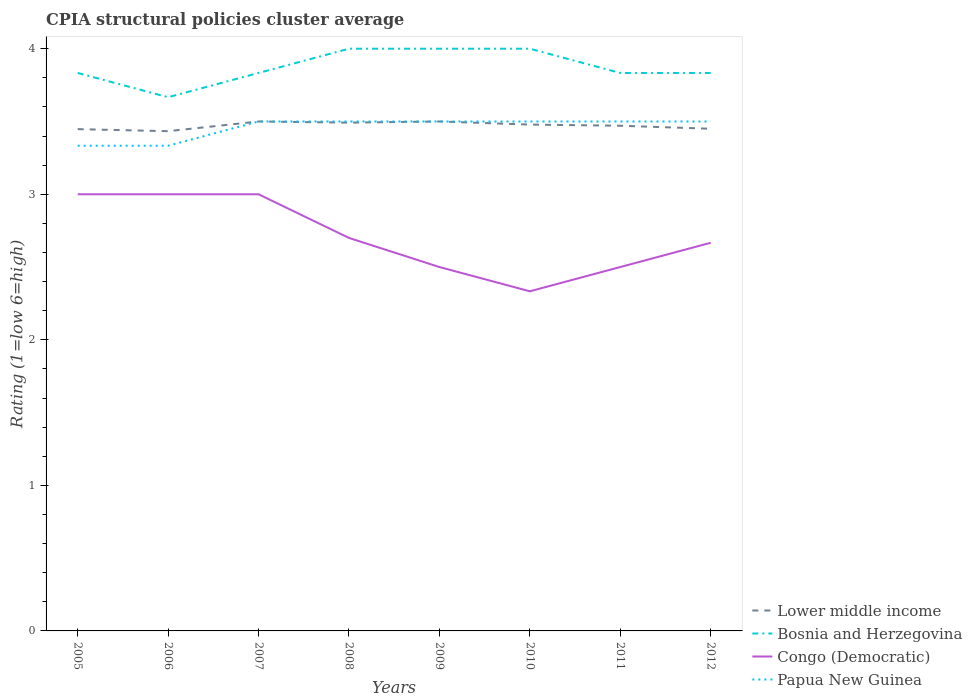Does the line corresponding to Bosnia and Herzegovina intersect with the line corresponding to Lower middle income?
Offer a very short reply. No. Across all years, what is the maximum CPIA rating in Congo (Democratic)?
Offer a terse response. 2.33. In which year was the CPIA rating in Congo (Democratic) maximum?
Provide a short and direct response. 2010. What is the total CPIA rating in Lower middle income in the graph?
Your answer should be compact. 0.02. What is the difference between the highest and the second highest CPIA rating in Congo (Democratic)?
Offer a very short reply. 0.67. What is the difference between the highest and the lowest CPIA rating in Papua New Guinea?
Your response must be concise. 6. Is the CPIA rating in Bosnia and Herzegovina strictly greater than the CPIA rating in Congo (Democratic) over the years?
Your response must be concise. No. How many lines are there?
Ensure brevity in your answer.  4. What is the difference between two consecutive major ticks on the Y-axis?
Make the answer very short. 1. Are the values on the major ticks of Y-axis written in scientific E-notation?
Keep it short and to the point. No. Does the graph contain grids?
Keep it short and to the point. No. Where does the legend appear in the graph?
Provide a succinct answer. Bottom right. How many legend labels are there?
Give a very brief answer. 4. What is the title of the graph?
Your response must be concise. CPIA structural policies cluster average. Does "French Polynesia" appear as one of the legend labels in the graph?
Keep it short and to the point. No. What is the label or title of the Y-axis?
Make the answer very short. Rating (1=low 6=high). What is the Rating (1=low 6=high) in Lower middle income in 2005?
Offer a very short reply. 3.45. What is the Rating (1=low 6=high) of Bosnia and Herzegovina in 2005?
Keep it short and to the point. 3.83. What is the Rating (1=low 6=high) in Papua New Guinea in 2005?
Give a very brief answer. 3.33. What is the Rating (1=low 6=high) of Lower middle income in 2006?
Provide a succinct answer. 3.43. What is the Rating (1=low 6=high) in Bosnia and Herzegovina in 2006?
Offer a very short reply. 3.67. What is the Rating (1=low 6=high) in Papua New Guinea in 2006?
Your answer should be compact. 3.33. What is the Rating (1=low 6=high) of Bosnia and Herzegovina in 2007?
Keep it short and to the point. 3.83. What is the Rating (1=low 6=high) of Papua New Guinea in 2007?
Ensure brevity in your answer.  3.5. What is the Rating (1=low 6=high) in Lower middle income in 2008?
Give a very brief answer. 3.49. What is the Rating (1=low 6=high) in Papua New Guinea in 2009?
Your answer should be compact. 3.5. What is the Rating (1=low 6=high) of Lower middle income in 2010?
Your answer should be very brief. 3.48. What is the Rating (1=low 6=high) in Congo (Democratic) in 2010?
Make the answer very short. 2.33. What is the Rating (1=low 6=high) of Papua New Guinea in 2010?
Offer a terse response. 3.5. What is the Rating (1=low 6=high) of Lower middle income in 2011?
Provide a short and direct response. 3.47. What is the Rating (1=low 6=high) of Bosnia and Herzegovina in 2011?
Your response must be concise. 3.83. What is the Rating (1=low 6=high) of Congo (Democratic) in 2011?
Offer a terse response. 2.5. What is the Rating (1=low 6=high) of Lower middle income in 2012?
Your response must be concise. 3.45. What is the Rating (1=low 6=high) in Bosnia and Herzegovina in 2012?
Offer a very short reply. 3.83. What is the Rating (1=low 6=high) of Congo (Democratic) in 2012?
Your answer should be compact. 2.67. Across all years, what is the maximum Rating (1=low 6=high) of Lower middle income?
Offer a very short reply. 3.5. Across all years, what is the maximum Rating (1=low 6=high) of Congo (Democratic)?
Give a very brief answer. 3. Across all years, what is the minimum Rating (1=low 6=high) of Lower middle income?
Ensure brevity in your answer.  3.43. Across all years, what is the minimum Rating (1=low 6=high) in Bosnia and Herzegovina?
Your response must be concise. 3.67. Across all years, what is the minimum Rating (1=low 6=high) in Congo (Democratic)?
Give a very brief answer. 2.33. Across all years, what is the minimum Rating (1=low 6=high) of Papua New Guinea?
Keep it short and to the point. 3.33. What is the total Rating (1=low 6=high) of Lower middle income in the graph?
Provide a short and direct response. 27.77. What is the total Rating (1=low 6=high) in Congo (Democratic) in the graph?
Make the answer very short. 21.7. What is the total Rating (1=low 6=high) of Papua New Guinea in the graph?
Offer a terse response. 27.67. What is the difference between the Rating (1=low 6=high) of Lower middle income in 2005 and that in 2006?
Offer a terse response. 0.01. What is the difference between the Rating (1=low 6=high) in Congo (Democratic) in 2005 and that in 2006?
Your answer should be very brief. 0. What is the difference between the Rating (1=low 6=high) of Lower middle income in 2005 and that in 2007?
Provide a succinct answer. -0.05. What is the difference between the Rating (1=low 6=high) in Congo (Democratic) in 2005 and that in 2007?
Make the answer very short. 0. What is the difference between the Rating (1=low 6=high) in Papua New Guinea in 2005 and that in 2007?
Make the answer very short. -0.17. What is the difference between the Rating (1=low 6=high) in Lower middle income in 2005 and that in 2008?
Your answer should be very brief. -0.04. What is the difference between the Rating (1=low 6=high) of Lower middle income in 2005 and that in 2009?
Your response must be concise. -0.05. What is the difference between the Rating (1=low 6=high) in Lower middle income in 2005 and that in 2010?
Offer a terse response. -0.03. What is the difference between the Rating (1=low 6=high) in Bosnia and Herzegovina in 2005 and that in 2010?
Ensure brevity in your answer.  -0.17. What is the difference between the Rating (1=low 6=high) of Congo (Democratic) in 2005 and that in 2010?
Your answer should be compact. 0.67. What is the difference between the Rating (1=low 6=high) of Papua New Guinea in 2005 and that in 2010?
Make the answer very short. -0.17. What is the difference between the Rating (1=low 6=high) in Lower middle income in 2005 and that in 2011?
Provide a succinct answer. -0.02. What is the difference between the Rating (1=low 6=high) of Bosnia and Herzegovina in 2005 and that in 2011?
Your answer should be compact. 0. What is the difference between the Rating (1=low 6=high) in Congo (Democratic) in 2005 and that in 2011?
Provide a succinct answer. 0.5. What is the difference between the Rating (1=low 6=high) in Lower middle income in 2005 and that in 2012?
Your response must be concise. -0. What is the difference between the Rating (1=low 6=high) in Papua New Guinea in 2005 and that in 2012?
Your answer should be compact. -0.17. What is the difference between the Rating (1=low 6=high) of Lower middle income in 2006 and that in 2007?
Your answer should be very brief. -0.07. What is the difference between the Rating (1=low 6=high) of Bosnia and Herzegovina in 2006 and that in 2007?
Your answer should be compact. -0.17. What is the difference between the Rating (1=low 6=high) of Congo (Democratic) in 2006 and that in 2007?
Make the answer very short. 0. What is the difference between the Rating (1=low 6=high) of Lower middle income in 2006 and that in 2008?
Provide a succinct answer. -0.06. What is the difference between the Rating (1=low 6=high) of Congo (Democratic) in 2006 and that in 2008?
Your response must be concise. 0.3. What is the difference between the Rating (1=low 6=high) of Lower middle income in 2006 and that in 2009?
Offer a terse response. -0.07. What is the difference between the Rating (1=low 6=high) in Papua New Guinea in 2006 and that in 2009?
Make the answer very short. -0.17. What is the difference between the Rating (1=low 6=high) in Lower middle income in 2006 and that in 2010?
Provide a short and direct response. -0.05. What is the difference between the Rating (1=low 6=high) of Bosnia and Herzegovina in 2006 and that in 2010?
Your answer should be very brief. -0.33. What is the difference between the Rating (1=low 6=high) of Lower middle income in 2006 and that in 2011?
Give a very brief answer. -0.04. What is the difference between the Rating (1=low 6=high) of Congo (Democratic) in 2006 and that in 2011?
Keep it short and to the point. 0.5. What is the difference between the Rating (1=low 6=high) in Lower middle income in 2006 and that in 2012?
Ensure brevity in your answer.  -0.02. What is the difference between the Rating (1=low 6=high) of Congo (Democratic) in 2006 and that in 2012?
Your answer should be compact. 0.33. What is the difference between the Rating (1=low 6=high) of Papua New Guinea in 2006 and that in 2012?
Offer a terse response. -0.17. What is the difference between the Rating (1=low 6=high) in Lower middle income in 2007 and that in 2008?
Keep it short and to the point. 0.01. What is the difference between the Rating (1=low 6=high) in Papua New Guinea in 2007 and that in 2008?
Keep it short and to the point. 0. What is the difference between the Rating (1=low 6=high) of Congo (Democratic) in 2007 and that in 2009?
Ensure brevity in your answer.  0.5. What is the difference between the Rating (1=low 6=high) in Lower middle income in 2007 and that in 2010?
Your response must be concise. 0.02. What is the difference between the Rating (1=low 6=high) in Bosnia and Herzegovina in 2007 and that in 2010?
Provide a short and direct response. -0.17. What is the difference between the Rating (1=low 6=high) in Lower middle income in 2007 and that in 2011?
Provide a short and direct response. 0.03. What is the difference between the Rating (1=low 6=high) of Congo (Democratic) in 2007 and that in 2011?
Make the answer very short. 0.5. What is the difference between the Rating (1=low 6=high) in Papua New Guinea in 2007 and that in 2011?
Give a very brief answer. 0. What is the difference between the Rating (1=low 6=high) of Lower middle income in 2007 and that in 2012?
Provide a short and direct response. 0.05. What is the difference between the Rating (1=low 6=high) in Papua New Guinea in 2007 and that in 2012?
Give a very brief answer. 0. What is the difference between the Rating (1=low 6=high) in Lower middle income in 2008 and that in 2009?
Give a very brief answer. -0.01. What is the difference between the Rating (1=low 6=high) of Bosnia and Herzegovina in 2008 and that in 2009?
Offer a very short reply. 0. What is the difference between the Rating (1=low 6=high) of Congo (Democratic) in 2008 and that in 2009?
Keep it short and to the point. 0.2. What is the difference between the Rating (1=low 6=high) in Papua New Guinea in 2008 and that in 2009?
Keep it short and to the point. 0. What is the difference between the Rating (1=low 6=high) in Lower middle income in 2008 and that in 2010?
Provide a short and direct response. 0.01. What is the difference between the Rating (1=low 6=high) of Congo (Democratic) in 2008 and that in 2010?
Your answer should be compact. 0.37. What is the difference between the Rating (1=low 6=high) in Papua New Guinea in 2008 and that in 2010?
Provide a short and direct response. 0. What is the difference between the Rating (1=low 6=high) of Lower middle income in 2008 and that in 2011?
Ensure brevity in your answer.  0.02. What is the difference between the Rating (1=low 6=high) in Lower middle income in 2008 and that in 2012?
Provide a short and direct response. 0.04. What is the difference between the Rating (1=low 6=high) of Bosnia and Herzegovina in 2008 and that in 2012?
Your response must be concise. 0.17. What is the difference between the Rating (1=low 6=high) in Congo (Democratic) in 2008 and that in 2012?
Give a very brief answer. 0.03. What is the difference between the Rating (1=low 6=high) of Papua New Guinea in 2008 and that in 2012?
Make the answer very short. 0. What is the difference between the Rating (1=low 6=high) in Lower middle income in 2009 and that in 2010?
Your answer should be very brief. 0.02. What is the difference between the Rating (1=low 6=high) in Bosnia and Herzegovina in 2009 and that in 2010?
Your answer should be very brief. 0. What is the difference between the Rating (1=low 6=high) of Lower middle income in 2009 and that in 2011?
Provide a succinct answer. 0.03. What is the difference between the Rating (1=low 6=high) of Congo (Democratic) in 2009 and that in 2011?
Provide a short and direct response. 0. What is the difference between the Rating (1=low 6=high) of Papua New Guinea in 2009 and that in 2011?
Give a very brief answer. 0. What is the difference between the Rating (1=low 6=high) of Papua New Guinea in 2009 and that in 2012?
Provide a short and direct response. 0. What is the difference between the Rating (1=low 6=high) of Lower middle income in 2010 and that in 2011?
Your response must be concise. 0.01. What is the difference between the Rating (1=low 6=high) of Lower middle income in 2010 and that in 2012?
Provide a short and direct response. 0.03. What is the difference between the Rating (1=low 6=high) of Bosnia and Herzegovina in 2010 and that in 2012?
Give a very brief answer. 0.17. What is the difference between the Rating (1=low 6=high) in Congo (Democratic) in 2010 and that in 2012?
Your answer should be compact. -0.33. What is the difference between the Rating (1=low 6=high) in Lower middle income in 2011 and that in 2012?
Your answer should be very brief. 0.02. What is the difference between the Rating (1=low 6=high) of Bosnia and Herzegovina in 2011 and that in 2012?
Your answer should be very brief. 0. What is the difference between the Rating (1=low 6=high) of Lower middle income in 2005 and the Rating (1=low 6=high) of Bosnia and Herzegovina in 2006?
Provide a succinct answer. -0.22. What is the difference between the Rating (1=low 6=high) in Lower middle income in 2005 and the Rating (1=low 6=high) in Congo (Democratic) in 2006?
Make the answer very short. 0.45. What is the difference between the Rating (1=low 6=high) of Lower middle income in 2005 and the Rating (1=low 6=high) of Papua New Guinea in 2006?
Provide a short and direct response. 0.11. What is the difference between the Rating (1=low 6=high) of Bosnia and Herzegovina in 2005 and the Rating (1=low 6=high) of Congo (Democratic) in 2006?
Give a very brief answer. 0.83. What is the difference between the Rating (1=low 6=high) of Lower middle income in 2005 and the Rating (1=low 6=high) of Bosnia and Herzegovina in 2007?
Your answer should be very brief. -0.39. What is the difference between the Rating (1=low 6=high) in Lower middle income in 2005 and the Rating (1=low 6=high) in Congo (Democratic) in 2007?
Provide a succinct answer. 0.45. What is the difference between the Rating (1=low 6=high) of Lower middle income in 2005 and the Rating (1=low 6=high) of Papua New Guinea in 2007?
Make the answer very short. -0.05. What is the difference between the Rating (1=low 6=high) of Bosnia and Herzegovina in 2005 and the Rating (1=low 6=high) of Congo (Democratic) in 2007?
Your answer should be compact. 0.83. What is the difference between the Rating (1=low 6=high) of Congo (Democratic) in 2005 and the Rating (1=low 6=high) of Papua New Guinea in 2007?
Your answer should be very brief. -0.5. What is the difference between the Rating (1=low 6=high) of Lower middle income in 2005 and the Rating (1=low 6=high) of Bosnia and Herzegovina in 2008?
Offer a very short reply. -0.55. What is the difference between the Rating (1=low 6=high) of Lower middle income in 2005 and the Rating (1=low 6=high) of Congo (Democratic) in 2008?
Offer a terse response. 0.75. What is the difference between the Rating (1=low 6=high) of Lower middle income in 2005 and the Rating (1=low 6=high) of Papua New Guinea in 2008?
Provide a succinct answer. -0.05. What is the difference between the Rating (1=low 6=high) of Bosnia and Herzegovina in 2005 and the Rating (1=low 6=high) of Congo (Democratic) in 2008?
Provide a short and direct response. 1.13. What is the difference between the Rating (1=low 6=high) in Bosnia and Herzegovina in 2005 and the Rating (1=low 6=high) in Papua New Guinea in 2008?
Your answer should be compact. 0.33. What is the difference between the Rating (1=low 6=high) of Lower middle income in 2005 and the Rating (1=low 6=high) of Bosnia and Herzegovina in 2009?
Make the answer very short. -0.55. What is the difference between the Rating (1=low 6=high) in Lower middle income in 2005 and the Rating (1=low 6=high) in Papua New Guinea in 2009?
Keep it short and to the point. -0.05. What is the difference between the Rating (1=low 6=high) in Congo (Democratic) in 2005 and the Rating (1=low 6=high) in Papua New Guinea in 2009?
Your answer should be compact. -0.5. What is the difference between the Rating (1=low 6=high) in Lower middle income in 2005 and the Rating (1=low 6=high) in Bosnia and Herzegovina in 2010?
Ensure brevity in your answer.  -0.55. What is the difference between the Rating (1=low 6=high) in Lower middle income in 2005 and the Rating (1=low 6=high) in Congo (Democratic) in 2010?
Offer a terse response. 1.11. What is the difference between the Rating (1=low 6=high) of Lower middle income in 2005 and the Rating (1=low 6=high) of Papua New Guinea in 2010?
Give a very brief answer. -0.05. What is the difference between the Rating (1=low 6=high) of Bosnia and Herzegovina in 2005 and the Rating (1=low 6=high) of Congo (Democratic) in 2010?
Keep it short and to the point. 1.5. What is the difference between the Rating (1=low 6=high) of Lower middle income in 2005 and the Rating (1=low 6=high) of Bosnia and Herzegovina in 2011?
Provide a succinct answer. -0.39. What is the difference between the Rating (1=low 6=high) in Lower middle income in 2005 and the Rating (1=low 6=high) in Congo (Democratic) in 2011?
Keep it short and to the point. 0.95. What is the difference between the Rating (1=low 6=high) of Lower middle income in 2005 and the Rating (1=low 6=high) of Papua New Guinea in 2011?
Offer a terse response. -0.05. What is the difference between the Rating (1=low 6=high) of Bosnia and Herzegovina in 2005 and the Rating (1=low 6=high) of Congo (Democratic) in 2011?
Give a very brief answer. 1.33. What is the difference between the Rating (1=low 6=high) of Lower middle income in 2005 and the Rating (1=low 6=high) of Bosnia and Herzegovina in 2012?
Ensure brevity in your answer.  -0.39. What is the difference between the Rating (1=low 6=high) of Lower middle income in 2005 and the Rating (1=low 6=high) of Congo (Democratic) in 2012?
Offer a terse response. 0.78. What is the difference between the Rating (1=low 6=high) of Lower middle income in 2005 and the Rating (1=low 6=high) of Papua New Guinea in 2012?
Your response must be concise. -0.05. What is the difference between the Rating (1=low 6=high) in Bosnia and Herzegovina in 2005 and the Rating (1=low 6=high) in Papua New Guinea in 2012?
Make the answer very short. 0.33. What is the difference between the Rating (1=low 6=high) of Congo (Democratic) in 2005 and the Rating (1=low 6=high) of Papua New Guinea in 2012?
Offer a terse response. -0.5. What is the difference between the Rating (1=low 6=high) of Lower middle income in 2006 and the Rating (1=low 6=high) of Bosnia and Herzegovina in 2007?
Your answer should be compact. -0.4. What is the difference between the Rating (1=low 6=high) in Lower middle income in 2006 and the Rating (1=low 6=high) in Congo (Democratic) in 2007?
Ensure brevity in your answer.  0.43. What is the difference between the Rating (1=low 6=high) in Lower middle income in 2006 and the Rating (1=low 6=high) in Papua New Guinea in 2007?
Offer a terse response. -0.07. What is the difference between the Rating (1=low 6=high) in Bosnia and Herzegovina in 2006 and the Rating (1=low 6=high) in Congo (Democratic) in 2007?
Offer a very short reply. 0.67. What is the difference between the Rating (1=low 6=high) of Congo (Democratic) in 2006 and the Rating (1=low 6=high) of Papua New Guinea in 2007?
Keep it short and to the point. -0.5. What is the difference between the Rating (1=low 6=high) in Lower middle income in 2006 and the Rating (1=low 6=high) in Bosnia and Herzegovina in 2008?
Provide a short and direct response. -0.57. What is the difference between the Rating (1=low 6=high) of Lower middle income in 2006 and the Rating (1=low 6=high) of Congo (Democratic) in 2008?
Keep it short and to the point. 0.73. What is the difference between the Rating (1=low 6=high) in Lower middle income in 2006 and the Rating (1=low 6=high) in Papua New Guinea in 2008?
Provide a short and direct response. -0.07. What is the difference between the Rating (1=low 6=high) in Bosnia and Herzegovina in 2006 and the Rating (1=low 6=high) in Congo (Democratic) in 2008?
Offer a very short reply. 0.97. What is the difference between the Rating (1=low 6=high) of Lower middle income in 2006 and the Rating (1=low 6=high) of Bosnia and Herzegovina in 2009?
Offer a very short reply. -0.57. What is the difference between the Rating (1=low 6=high) in Lower middle income in 2006 and the Rating (1=low 6=high) in Congo (Democratic) in 2009?
Your answer should be very brief. 0.93. What is the difference between the Rating (1=low 6=high) in Lower middle income in 2006 and the Rating (1=low 6=high) in Papua New Guinea in 2009?
Ensure brevity in your answer.  -0.07. What is the difference between the Rating (1=low 6=high) of Congo (Democratic) in 2006 and the Rating (1=low 6=high) of Papua New Guinea in 2009?
Make the answer very short. -0.5. What is the difference between the Rating (1=low 6=high) in Lower middle income in 2006 and the Rating (1=low 6=high) in Bosnia and Herzegovina in 2010?
Offer a very short reply. -0.57. What is the difference between the Rating (1=low 6=high) in Lower middle income in 2006 and the Rating (1=low 6=high) in Congo (Democratic) in 2010?
Your answer should be very brief. 1.1. What is the difference between the Rating (1=low 6=high) of Lower middle income in 2006 and the Rating (1=low 6=high) of Papua New Guinea in 2010?
Offer a very short reply. -0.07. What is the difference between the Rating (1=low 6=high) of Bosnia and Herzegovina in 2006 and the Rating (1=low 6=high) of Papua New Guinea in 2010?
Make the answer very short. 0.17. What is the difference between the Rating (1=low 6=high) of Congo (Democratic) in 2006 and the Rating (1=low 6=high) of Papua New Guinea in 2010?
Ensure brevity in your answer.  -0.5. What is the difference between the Rating (1=low 6=high) in Lower middle income in 2006 and the Rating (1=low 6=high) in Bosnia and Herzegovina in 2011?
Keep it short and to the point. -0.4. What is the difference between the Rating (1=low 6=high) of Lower middle income in 2006 and the Rating (1=low 6=high) of Congo (Democratic) in 2011?
Give a very brief answer. 0.93. What is the difference between the Rating (1=low 6=high) in Lower middle income in 2006 and the Rating (1=low 6=high) in Papua New Guinea in 2011?
Your answer should be compact. -0.07. What is the difference between the Rating (1=low 6=high) in Lower middle income in 2006 and the Rating (1=low 6=high) in Congo (Democratic) in 2012?
Keep it short and to the point. 0.77. What is the difference between the Rating (1=low 6=high) in Lower middle income in 2006 and the Rating (1=low 6=high) in Papua New Guinea in 2012?
Provide a short and direct response. -0.07. What is the difference between the Rating (1=low 6=high) in Congo (Democratic) in 2006 and the Rating (1=low 6=high) in Papua New Guinea in 2012?
Offer a terse response. -0.5. What is the difference between the Rating (1=low 6=high) of Lower middle income in 2007 and the Rating (1=low 6=high) of Bosnia and Herzegovina in 2008?
Your response must be concise. -0.5. What is the difference between the Rating (1=low 6=high) of Lower middle income in 2007 and the Rating (1=low 6=high) of Congo (Democratic) in 2008?
Provide a short and direct response. 0.8. What is the difference between the Rating (1=low 6=high) in Lower middle income in 2007 and the Rating (1=low 6=high) in Papua New Guinea in 2008?
Give a very brief answer. 0. What is the difference between the Rating (1=low 6=high) in Bosnia and Herzegovina in 2007 and the Rating (1=low 6=high) in Congo (Democratic) in 2008?
Give a very brief answer. 1.13. What is the difference between the Rating (1=low 6=high) in Bosnia and Herzegovina in 2007 and the Rating (1=low 6=high) in Papua New Guinea in 2008?
Offer a very short reply. 0.33. What is the difference between the Rating (1=low 6=high) in Lower middle income in 2007 and the Rating (1=low 6=high) in Congo (Democratic) in 2009?
Offer a terse response. 1. What is the difference between the Rating (1=low 6=high) of Lower middle income in 2007 and the Rating (1=low 6=high) of Papua New Guinea in 2009?
Give a very brief answer. 0. What is the difference between the Rating (1=low 6=high) of Bosnia and Herzegovina in 2007 and the Rating (1=low 6=high) of Congo (Democratic) in 2009?
Your response must be concise. 1.33. What is the difference between the Rating (1=low 6=high) in Bosnia and Herzegovina in 2007 and the Rating (1=low 6=high) in Papua New Guinea in 2009?
Your answer should be compact. 0.33. What is the difference between the Rating (1=low 6=high) in Lower middle income in 2007 and the Rating (1=low 6=high) in Bosnia and Herzegovina in 2010?
Keep it short and to the point. -0.5. What is the difference between the Rating (1=low 6=high) of Lower middle income in 2007 and the Rating (1=low 6=high) of Congo (Democratic) in 2010?
Ensure brevity in your answer.  1.17. What is the difference between the Rating (1=low 6=high) in Lower middle income in 2007 and the Rating (1=low 6=high) in Papua New Guinea in 2010?
Give a very brief answer. 0. What is the difference between the Rating (1=low 6=high) of Bosnia and Herzegovina in 2007 and the Rating (1=low 6=high) of Congo (Democratic) in 2010?
Your answer should be compact. 1.5. What is the difference between the Rating (1=low 6=high) of Bosnia and Herzegovina in 2007 and the Rating (1=low 6=high) of Papua New Guinea in 2010?
Provide a short and direct response. 0.33. What is the difference between the Rating (1=low 6=high) of Congo (Democratic) in 2007 and the Rating (1=low 6=high) of Papua New Guinea in 2010?
Offer a very short reply. -0.5. What is the difference between the Rating (1=low 6=high) in Lower middle income in 2007 and the Rating (1=low 6=high) in Congo (Democratic) in 2011?
Make the answer very short. 1. What is the difference between the Rating (1=low 6=high) in Lower middle income in 2007 and the Rating (1=low 6=high) in Papua New Guinea in 2011?
Your answer should be compact. 0. What is the difference between the Rating (1=low 6=high) in Congo (Democratic) in 2007 and the Rating (1=low 6=high) in Papua New Guinea in 2011?
Offer a very short reply. -0.5. What is the difference between the Rating (1=low 6=high) of Lower middle income in 2007 and the Rating (1=low 6=high) of Bosnia and Herzegovina in 2012?
Offer a terse response. -0.33. What is the difference between the Rating (1=low 6=high) in Lower middle income in 2007 and the Rating (1=low 6=high) in Congo (Democratic) in 2012?
Your response must be concise. 0.83. What is the difference between the Rating (1=low 6=high) of Bosnia and Herzegovina in 2007 and the Rating (1=low 6=high) of Congo (Democratic) in 2012?
Offer a terse response. 1.17. What is the difference between the Rating (1=low 6=high) of Bosnia and Herzegovina in 2007 and the Rating (1=low 6=high) of Papua New Guinea in 2012?
Provide a succinct answer. 0.33. What is the difference between the Rating (1=low 6=high) of Congo (Democratic) in 2007 and the Rating (1=low 6=high) of Papua New Guinea in 2012?
Keep it short and to the point. -0.5. What is the difference between the Rating (1=low 6=high) in Lower middle income in 2008 and the Rating (1=low 6=high) in Bosnia and Herzegovina in 2009?
Your response must be concise. -0.51. What is the difference between the Rating (1=low 6=high) of Lower middle income in 2008 and the Rating (1=low 6=high) of Congo (Democratic) in 2009?
Give a very brief answer. 0.99. What is the difference between the Rating (1=low 6=high) of Lower middle income in 2008 and the Rating (1=low 6=high) of Papua New Guinea in 2009?
Ensure brevity in your answer.  -0.01. What is the difference between the Rating (1=low 6=high) of Lower middle income in 2008 and the Rating (1=low 6=high) of Bosnia and Herzegovina in 2010?
Give a very brief answer. -0.51. What is the difference between the Rating (1=low 6=high) in Lower middle income in 2008 and the Rating (1=low 6=high) in Congo (Democratic) in 2010?
Your answer should be compact. 1.16. What is the difference between the Rating (1=low 6=high) of Lower middle income in 2008 and the Rating (1=low 6=high) of Papua New Guinea in 2010?
Your response must be concise. -0.01. What is the difference between the Rating (1=low 6=high) of Bosnia and Herzegovina in 2008 and the Rating (1=low 6=high) of Congo (Democratic) in 2010?
Give a very brief answer. 1.67. What is the difference between the Rating (1=low 6=high) of Lower middle income in 2008 and the Rating (1=low 6=high) of Bosnia and Herzegovina in 2011?
Your answer should be very brief. -0.34. What is the difference between the Rating (1=low 6=high) in Lower middle income in 2008 and the Rating (1=low 6=high) in Congo (Democratic) in 2011?
Your response must be concise. 0.99. What is the difference between the Rating (1=low 6=high) in Lower middle income in 2008 and the Rating (1=low 6=high) in Papua New Guinea in 2011?
Offer a terse response. -0.01. What is the difference between the Rating (1=low 6=high) in Bosnia and Herzegovina in 2008 and the Rating (1=low 6=high) in Papua New Guinea in 2011?
Your answer should be very brief. 0.5. What is the difference between the Rating (1=low 6=high) in Lower middle income in 2008 and the Rating (1=low 6=high) in Bosnia and Herzegovina in 2012?
Provide a short and direct response. -0.34. What is the difference between the Rating (1=low 6=high) of Lower middle income in 2008 and the Rating (1=low 6=high) of Congo (Democratic) in 2012?
Make the answer very short. 0.83. What is the difference between the Rating (1=low 6=high) in Lower middle income in 2008 and the Rating (1=low 6=high) in Papua New Guinea in 2012?
Make the answer very short. -0.01. What is the difference between the Rating (1=low 6=high) in Bosnia and Herzegovina in 2008 and the Rating (1=low 6=high) in Congo (Democratic) in 2012?
Keep it short and to the point. 1.33. What is the difference between the Rating (1=low 6=high) of Bosnia and Herzegovina in 2008 and the Rating (1=low 6=high) of Papua New Guinea in 2012?
Ensure brevity in your answer.  0.5. What is the difference between the Rating (1=low 6=high) in Congo (Democratic) in 2008 and the Rating (1=low 6=high) in Papua New Guinea in 2012?
Your answer should be very brief. -0.8. What is the difference between the Rating (1=low 6=high) of Lower middle income in 2009 and the Rating (1=low 6=high) of Congo (Democratic) in 2010?
Provide a short and direct response. 1.17. What is the difference between the Rating (1=low 6=high) in Lower middle income in 2009 and the Rating (1=low 6=high) in Papua New Guinea in 2010?
Offer a very short reply. 0. What is the difference between the Rating (1=low 6=high) in Bosnia and Herzegovina in 2009 and the Rating (1=low 6=high) in Papua New Guinea in 2010?
Give a very brief answer. 0.5. What is the difference between the Rating (1=low 6=high) of Lower middle income in 2009 and the Rating (1=low 6=high) of Bosnia and Herzegovina in 2011?
Ensure brevity in your answer.  -0.33. What is the difference between the Rating (1=low 6=high) in Lower middle income in 2009 and the Rating (1=low 6=high) in Congo (Democratic) in 2011?
Offer a terse response. 1. What is the difference between the Rating (1=low 6=high) of Bosnia and Herzegovina in 2009 and the Rating (1=low 6=high) of Congo (Democratic) in 2011?
Offer a terse response. 1.5. What is the difference between the Rating (1=low 6=high) of Bosnia and Herzegovina in 2009 and the Rating (1=low 6=high) of Papua New Guinea in 2011?
Your response must be concise. 0.5. What is the difference between the Rating (1=low 6=high) in Congo (Democratic) in 2009 and the Rating (1=low 6=high) in Papua New Guinea in 2011?
Keep it short and to the point. -1. What is the difference between the Rating (1=low 6=high) in Lower middle income in 2009 and the Rating (1=low 6=high) in Papua New Guinea in 2012?
Give a very brief answer. 0. What is the difference between the Rating (1=low 6=high) of Lower middle income in 2010 and the Rating (1=low 6=high) of Bosnia and Herzegovina in 2011?
Provide a succinct answer. -0.35. What is the difference between the Rating (1=low 6=high) in Lower middle income in 2010 and the Rating (1=low 6=high) in Congo (Democratic) in 2011?
Offer a terse response. 0.98. What is the difference between the Rating (1=low 6=high) of Lower middle income in 2010 and the Rating (1=low 6=high) of Papua New Guinea in 2011?
Provide a succinct answer. -0.02. What is the difference between the Rating (1=low 6=high) in Bosnia and Herzegovina in 2010 and the Rating (1=low 6=high) in Papua New Guinea in 2011?
Ensure brevity in your answer.  0.5. What is the difference between the Rating (1=low 6=high) in Congo (Democratic) in 2010 and the Rating (1=low 6=high) in Papua New Guinea in 2011?
Offer a very short reply. -1.17. What is the difference between the Rating (1=low 6=high) of Lower middle income in 2010 and the Rating (1=low 6=high) of Bosnia and Herzegovina in 2012?
Provide a short and direct response. -0.35. What is the difference between the Rating (1=low 6=high) in Lower middle income in 2010 and the Rating (1=low 6=high) in Congo (Democratic) in 2012?
Your response must be concise. 0.81. What is the difference between the Rating (1=low 6=high) in Lower middle income in 2010 and the Rating (1=low 6=high) in Papua New Guinea in 2012?
Your answer should be compact. -0.02. What is the difference between the Rating (1=low 6=high) in Bosnia and Herzegovina in 2010 and the Rating (1=low 6=high) in Congo (Democratic) in 2012?
Give a very brief answer. 1.33. What is the difference between the Rating (1=low 6=high) in Congo (Democratic) in 2010 and the Rating (1=low 6=high) in Papua New Guinea in 2012?
Make the answer very short. -1.17. What is the difference between the Rating (1=low 6=high) of Lower middle income in 2011 and the Rating (1=low 6=high) of Bosnia and Herzegovina in 2012?
Provide a short and direct response. -0.36. What is the difference between the Rating (1=low 6=high) in Lower middle income in 2011 and the Rating (1=low 6=high) in Congo (Democratic) in 2012?
Your answer should be compact. 0.8. What is the difference between the Rating (1=low 6=high) of Lower middle income in 2011 and the Rating (1=low 6=high) of Papua New Guinea in 2012?
Provide a succinct answer. -0.03. What is the difference between the Rating (1=low 6=high) of Bosnia and Herzegovina in 2011 and the Rating (1=low 6=high) of Papua New Guinea in 2012?
Provide a succinct answer. 0.33. What is the difference between the Rating (1=low 6=high) of Congo (Democratic) in 2011 and the Rating (1=low 6=high) of Papua New Guinea in 2012?
Offer a terse response. -1. What is the average Rating (1=low 6=high) of Lower middle income per year?
Ensure brevity in your answer.  3.47. What is the average Rating (1=low 6=high) of Bosnia and Herzegovina per year?
Provide a short and direct response. 3.88. What is the average Rating (1=low 6=high) in Congo (Democratic) per year?
Make the answer very short. 2.71. What is the average Rating (1=low 6=high) in Papua New Guinea per year?
Your answer should be very brief. 3.46. In the year 2005, what is the difference between the Rating (1=low 6=high) of Lower middle income and Rating (1=low 6=high) of Bosnia and Herzegovina?
Ensure brevity in your answer.  -0.39. In the year 2005, what is the difference between the Rating (1=low 6=high) in Lower middle income and Rating (1=low 6=high) in Congo (Democratic)?
Provide a short and direct response. 0.45. In the year 2005, what is the difference between the Rating (1=low 6=high) in Lower middle income and Rating (1=low 6=high) in Papua New Guinea?
Provide a succinct answer. 0.11. In the year 2005, what is the difference between the Rating (1=low 6=high) of Bosnia and Herzegovina and Rating (1=low 6=high) of Congo (Democratic)?
Your response must be concise. 0.83. In the year 2006, what is the difference between the Rating (1=low 6=high) in Lower middle income and Rating (1=low 6=high) in Bosnia and Herzegovina?
Provide a succinct answer. -0.23. In the year 2006, what is the difference between the Rating (1=low 6=high) in Lower middle income and Rating (1=low 6=high) in Congo (Democratic)?
Make the answer very short. 0.43. In the year 2006, what is the difference between the Rating (1=low 6=high) in Lower middle income and Rating (1=low 6=high) in Papua New Guinea?
Keep it short and to the point. 0.1. In the year 2006, what is the difference between the Rating (1=low 6=high) of Congo (Democratic) and Rating (1=low 6=high) of Papua New Guinea?
Provide a short and direct response. -0.33. In the year 2007, what is the difference between the Rating (1=low 6=high) of Lower middle income and Rating (1=low 6=high) of Congo (Democratic)?
Give a very brief answer. 0.5. In the year 2007, what is the difference between the Rating (1=low 6=high) in Bosnia and Herzegovina and Rating (1=low 6=high) in Congo (Democratic)?
Your response must be concise. 0.83. In the year 2007, what is the difference between the Rating (1=low 6=high) in Bosnia and Herzegovina and Rating (1=low 6=high) in Papua New Guinea?
Your answer should be compact. 0.33. In the year 2008, what is the difference between the Rating (1=low 6=high) of Lower middle income and Rating (1=low 6=high) of Bosnia and Herzegovina?
Make the answer very short. -0.51. In the year 2008, what is the difference between the Rating (1=low 6=high) in Lower middle income and Rating (1=low 6=high) in Congo (Democratic)?
Offer a terse response. 0.79. In the year 2008, what is the difference between the Rating (1=low 6=high) of Lower middle income and Rating (1=low 6=high) of Papua New Guinea?
Provide a succinct answer. -0.01. In the year 2008, what is the difference between the Rating (1=low 6=high) in Bosnia and Herzegovina and Rating (1=low 6=high) in Congo (Democratic)?
Your response must be concise. 1.3. In the year 2008, what is the difference between the Rating (1=low 6=high) in Bosnia and Herzegovina and Rating (1=low 6=high) in Papua New Guinea?
Your answer should be very brief. 0.5. In the year 2008, what is the difference between the Rating (1=low 6=high) in Congo (Democratic) and Rating (1=low 6=high) in Papua New Guinea?
Provide a succinct answer. -0.8. In the year 2009, what is the difference between the Rating (1=low 6=high) of Lower middle income and Rating (1=low 6=high) of Bosnia and Herzegovina?
Keep it short and to the point. -0.5. In the year 2009, what is the difference between the Rating (1=low 6=high) of Lower middle income and Rating (1=low 6=high) of Congo (Democratic)?
Your answer should be compact. 1. In the year 2009, what is the difference between the Rating (1=low 6=high) in Bosnia and Herzegovina and Rating (1=low 6=high) in Congo (Democratic)?
Your response must be concise. 1.5. In the year 2010, what is the difference between the Rating (1=low 6=high) of Lower middle income and Rating (1=low 6=high) of Bosnia and Herzegovina?
Offer a terse response. -0.52. In the year 2010, what is the difference between the Rating (1=low 6=high) of Lower middle income and Rating (1=low 6=high) of Congo (Democratic)?
Offer a very short reply. 1.15. In the year 2010, what is the difference between the Rating (1=low 6=high) in Lower middle income and Rating (1=low 6=high) in Papua New Guinea?
Your answer should be very brief. -0.02. In the year 2010, what is the difference between the Rating (1=low 6=high) of Bosnia and Herzegovina and Rating (1=low 6=high) of Congo (Democratic)?
Offer a very short reply. 1.67. In the year 2010, what is the difference between the Rating (1=low 6=high) of Bosnia and Herzegovina and Rating (1=low 6=high) of Papua New Guinea?
Your answer should be compact. 0.5. In the year 2010, what is the difference between the Rating (1=low 6=high) in Congo (Democratic) and Rating (1=low 6=high) in Papua New Guinea?
Offer a terse response. -1.17. In the year 2011, what is the difference between the Rating (1=low 6=high) in Lower middle income and Rating (1=low 6=high) in Bosnia and Herzegovina?
Make the answer very short. -0.36. In the year 2011, what is the difference between the Rating (1=low 6=high) in Lower middle income and Rating (1=low 6=high) in Congo (Democratic)?
Provide a short and direct response. 0.97. In the year 2011, what is the difference between the Rating (1=low 6=high) in Lower middle income and Rating (1=low 6=high) in Papua New Guinea?
Your answer should be very brief. -0.03. In the year 2011, what is the difference between the Rating (1=low 6=high) of Bosnia and Herzegovina and Rating (1=low 6=high) of Congo (Democratic)?
Keep it short and to the point. 1.33. In the year 2011, what is the difference between the Rating (1=low 6=high) in Congo (Democratic) and Rating (1=low 6=high) in Papua New Guinea?
Offer a terse response. -1. In the year 2012, what is the difference between the Rating (1=low 6=high) of Lower middle income and Rating (1=low 6=high) of Bosnia and Herzegovina?
Your answer should be very brief. -0.38. In the year 2012, what is the difference between the Rating (1=low 6=high) of Lower middle income and Rating (1=low 6=high) of Congo (Democratic)?
Your answer should be very brief. 0.78. In the year 2012, what is the difference between the Rating (1=low 6=high) in Bosnia and Herzegovina and Rating (1=low 6=high) in Papua New Guinea?
Your response must be concise. 0.33. In the year 2012, what is the difference between the Rating (1=low 6=high) of Congo (Democratic) and Rating (1=low 6=high) of Papua New Guinea?
Keep it short and to the point. -0.83. What is the ratio of the Rating (1=low 6=high) in Bosnia and Herzegovina in 2005 to that in 2006?
Offer a terse response. 1.05. What is the ratio of the Rating (1=low 6=high) in Papua New Guinea in 2005 to that in 2006?
Your response must be concise. 1. What is the ratio of the Rating (1=low 6=high) of Lower middle income in 2005 to that in 2007?
Offer a very short reply. 0.98. What is the ratio of the Rating (1=low 6=high) in Bosnia and Herzegovina in 2005 to that in 2007?
Offer a terse response. 1. What is the ratio of the Rating (1=low 6=high) of Congo (Democratic) in 2005 to that in 2007?
Your answer should be compact. 1. What is the ratio of the Rating (1=low 6=high) in Papua New Guinea in 2005 to that in 2007?
Your answer should be compact. 0.95. What is the ratio of the Rating (1=low 6=high) in Lower middle income in 2005 to that in 2008?
Give a very brief answer. 0.99. What is the ratio of the Rating (1=low 6=high) in Congo (Democratic) in 2005 to that in 2008?
Your answer should be very brief. 1.11. What is the ratio of the Rating (1=low 6=high) of Papua New Guinea in 2005 to that in 2008?
Offer a very short reply. 0.95. What is the ratio of the Rating (1=low 6=high) in Papua New Guinea in 2005 to that in 2009?
Offer a terse response. 0.95. What is the ratio of the Rating (1=low 6=high) in Bosnia and Herzegovina in 2005 to that in 2010?
Make the answer very short. 0.96. What is the ratio of the Rating (1=low 6=high) of Congo (Democratic) in 2005 to that in 2010?
Make the answer very short. 1.29. What is the ratio of the Rating (1=low 6=high) of Papua New Guinea in 2005 to that in 2010?
Offer a very short reply. 0.95. What is the ratio of the Rating (1=low 6=high) of Lower middle income in 2005 to that in 2011?
Provide a short and direct response. 0.99. What is the ratio of the Rating (1=low 6=high) of Bosnia and Herzegovina in 2005 to that in 2011?
Make the answer very short. 1. What is the ratio of the Rating (1=low 6=high) in Congo (Democratic) in 2005 to that in 2011?
Your answer should be compact. 1.2. What is the ratio of the Rating (1=low 6=high) in Congo (Democratic) in 2005 to that in 2012?
Make the answer very short. 1.12. What is the ratio of the Rating (1=low 6=high) of Bosnia and Herzegovina in 2006 to that in 2007?
Make the answer very short. 0.96. What is the ratio of the Rating (1=low 6=high) of Papua New Guinea in 2006 to that in 2007?
Your answer should be compact. 0.95. What is the ratio of the Rating (1=low 6=high) in Lower middle income in 2006 to that in 2008?
Provide a succinct answer. 0.98. What is the ratio of the Rating (1=low 6=high) of Bosnia and Herzegovina in 2006 to that in 2008?
Provide a succinct answer. 0.92. What is the ratio of the Rating (1=low 6=high) of Congo (Democratic) in 2006 to that in 2008?
Your answer should be compact. 1.11. What is the ratio of the Rating (1=low 6=high) of Papua New Guinea in 2006 to that in 2008?
Offer a very short reply. 0.95. What is the ratio of the Rating (1=low 6=high) of Papua New Guinea in 2006 to that in 2009?
Give a very brief answer. 0.95. What is the ratio of the Rating (1=low 6=high) in Bosnia and Herzegovina in 2006 to that in 2010?
Make the answer very short. 0.92. What is the ratio of the Rating (1=low 6=high) of Congo (Democratic) in 2006 to that in 2010?
Give a very brief answer. 1.29. What is the ratio of the Rating (1=low 6=high) in Lower middle income in 2006 to that in 2011?
Provide a succinct answer. 0.99. What is the ratio of the Rating (1=low 6=high) of Bosnia and Herzegovina in 2006 to that in 2011?
Give a very brief answer. 0.96. What is the ratio of the Rating (1=low 6=high) of Congo (Democratic) in 2006 to that in 2011?
Provide a succinct answer. 1.2. What is the ratio of the Rating (1=low 6=high) of Papua New Guinea in 2006 to that in 2011?
Your answer should be very brief. 0.95. What is the ratio of the Rating (1=low 6=high) in Lower middle income in 2006 to that in 2012?
Give a very brief answer. 1. What is the ratio of the Rating (1=low 6=high) of Bosnia and Herzegovina in 2006 to that in 2012?
Offer a terse response. 0.96. What is the ratio of the Rating (1=low 6=high) of Congo (Democratic) in 2006 to that in 2012?
Your answer should be very brief. 1.12. What is the ratio of the Rating (1=low 6=high) in Lower middle income in 2007 to that in 2008?
Provide a short and direct response. 1. What is the ratio of the Rating (1=low 6=high) of Congo (Democratic) in 2007 to that in 2008?
Provide a short and direct response. 1.11. What is the ratio of the Rating (1=low 6=high) of Papua New Guinea in 2007 to that in 2008?
Offer a terse response. 1. What is the ratio of the Rating (1=low 6=high) of Bosnia and Herzegovina in 2007 to that in 2009?
Ensure brevity in your answer.  0.96. What is the ratio of the Rating (1=low 6=high) of Lower middle income in 2007 to that in 2010?
Your response must be concise. 1.01. What is the ratio of the Rating (1=low 6=high) in Congo (Democratic) in 2007 to that in 2010?
Provide a succinct answer. 1.29. What is the ratio of the Rating (1=low 6=high) of Lower middle income in 2007 to that in 2011?
Keep it short and to the point. 1.01. What is the ratio of the Rating (1=low 6=high) in Bosnia and Herzegovina in 2007 to that in 2011?
Keep it short and to the point. 1. What is the ratio of the Rating (1=low 6=high) of Congo (Democratic) in 2007 to that in 2011?
Provide a succinct answer. 1.2. What is the ratio of the Rating (1=low 6=high) in Papua New Guinea in 2007 to that in 2011?
Keep it short and to the point. 1. What is the ratio of the Rating (1=low 6=high) of Lower middle income in 2007 to that in 2012?
Keep it short and to the point. 1.01. What is the ratio of the Rating (1=low 6=high) of Bosnia and Herzegovina in 2007 to that in 2012?
Your response must be concise. 1. What is the ratio of the Rating (1=low 6=high) of Bosnia and Herzegovina in 2008 to that in 2009?
Your answer should be compact. 1. What is the ratio of the Rating (1=low 6=high) of Congo (Democratic) in 2008 to that in 2009?
Ensure brevity in your answer.  1.08. What is the ratio of the Rating (1=low 6=high) of Lower middle income in 2008 to that in 2010?
Your response must be concise. 1. What is the ratio of the Rating (1=low 6=high) in Bosnia and Herzegovina in 2008 to that in 2010?
Provide a succinct answer. 1. What is the ratio of the Rating (1=low 6=high) of Congo (Democratic) in 2008 to that in 2010?
Offer a terse response. 1.16. What is the ratio of the Rating (1=low 6=high) of Papua New Guinea in 2008 to that in 2010?
Provide a short and direct response. 1. What is the ratio of the Rating (1=low 6=high) in Lower middle income in 2008 to that in 2011?
Keep it short and to the point. 1.01. What is the ratio of the Rating (1=low 6=high) of Bosnia and Herzegovina in 2008 to that in 2011?
Offer a terse response. 1.04. What is the ratio of the Rating (1=low 6=high) in Lower middle income in 2008 to that in 2012?
Make the answer very short. 1.01. What is the ratio of the Rating (1=low 6=high) in Bosnia and Herzegovina in 2008 to that in 2012?
Your answer should be very brief. 1.04. What is the ratio of the Rating (1=low 6=high) in Congo (Democratic) in 2008 to that in 2012?
Your answer should be compact. 1.01. What is the ratio of the Rating (1=low 6=high) of Lower middle income in 2009 to that in 2010?
Offer a terse response. 1.01. What is the ratio of the Rating (1=low 6=high) of Congo (Democratic) in 2009 to that in 2010?
Make the answer very short. 1.07. What is the ratio of the Rating (1=low 6=high) in Lower middle income in 2009 to that in 2011?
Your answer should be compact. 1.01. What is the ratio of the Rating (1=low 6=high) of Bosnia and Herzegovina in 2009 to that in 2011?
Offer a terse response. 1.04. What is the ratio of the Rating (1=low 6=high) in Congo (Democratic) in 2009 to that in 2011?
Keep it short and to the point. 1. What is the ratio of the Rating (1=low 6=high) of Lower middle income in 2009 to that in 2012?
Your response must be concise. 1.01. What is the ratio of the Rating (1=low 6=high) in Bosnia and Herzegovina in 2009 to that in 2012?
Ensure brevity in your answer.  1.04. What is the ratio of the Rating (1=low 6=high) in Congo (Democratic) in 2009 to that in 2012?
Provide a short and direct response. 0.94. What is the ratio of the Rating (1=low 6=high) of Bosnia and Herzegovina in 2010 to that in 2011?
Offer a very short reply. 1.04. What is the ratio of the Rating (1=low 6=high) of Papua New Guinea in 2010 to that in 2011?
Offer a terse response. 1. What is the ratio of the Rating (1=low 6=high) in Lower middle income in 2010 to that in 2012?
Provide a short and direct response. 1.01. What is the ratio of the Rating (1=low 6=high) of Bosnia and Herzegovina in 2010 to that in 2012?
Your response must be concise. 1.04. What is the difference between the highest and the second highest Rating (1=low 6=high) in Lower middle income?
Keep it short and to the point. 0. What is the difference between the highest and the second highest Rating (1=low 6=high) of Bosnia and Herzegovina?
Keep it short and to the point. 0. What is the difference between the highest and the second highest Rating (1=low 6=high) in Congo (Democratic)?
Your answer should be compact. 0. What is the difference between the highest and the second highest Rating (1=low 6=high) of Papua New Guinea?
Make the answer very short. 0. What is the difference between the highest and the lowest Rating (1=low 6=high) in Lower middle income?
Ensure brevity in your answer.  0.07. What is the difference between the highest and the lowest Rating (1=low 6=high) in Bosnia and Herzegovina?
Keep it short and to the point. 0.33. What is the difference between the highest and the lowest Rating (1=low 6=high) of Congo (Democratic)?
Your response must be concise. 0.67. What is the difference between the highest and the lowest Rating (1=low 6=high) in Papua New Guinea?
Give a very brief answer. 0.17. 